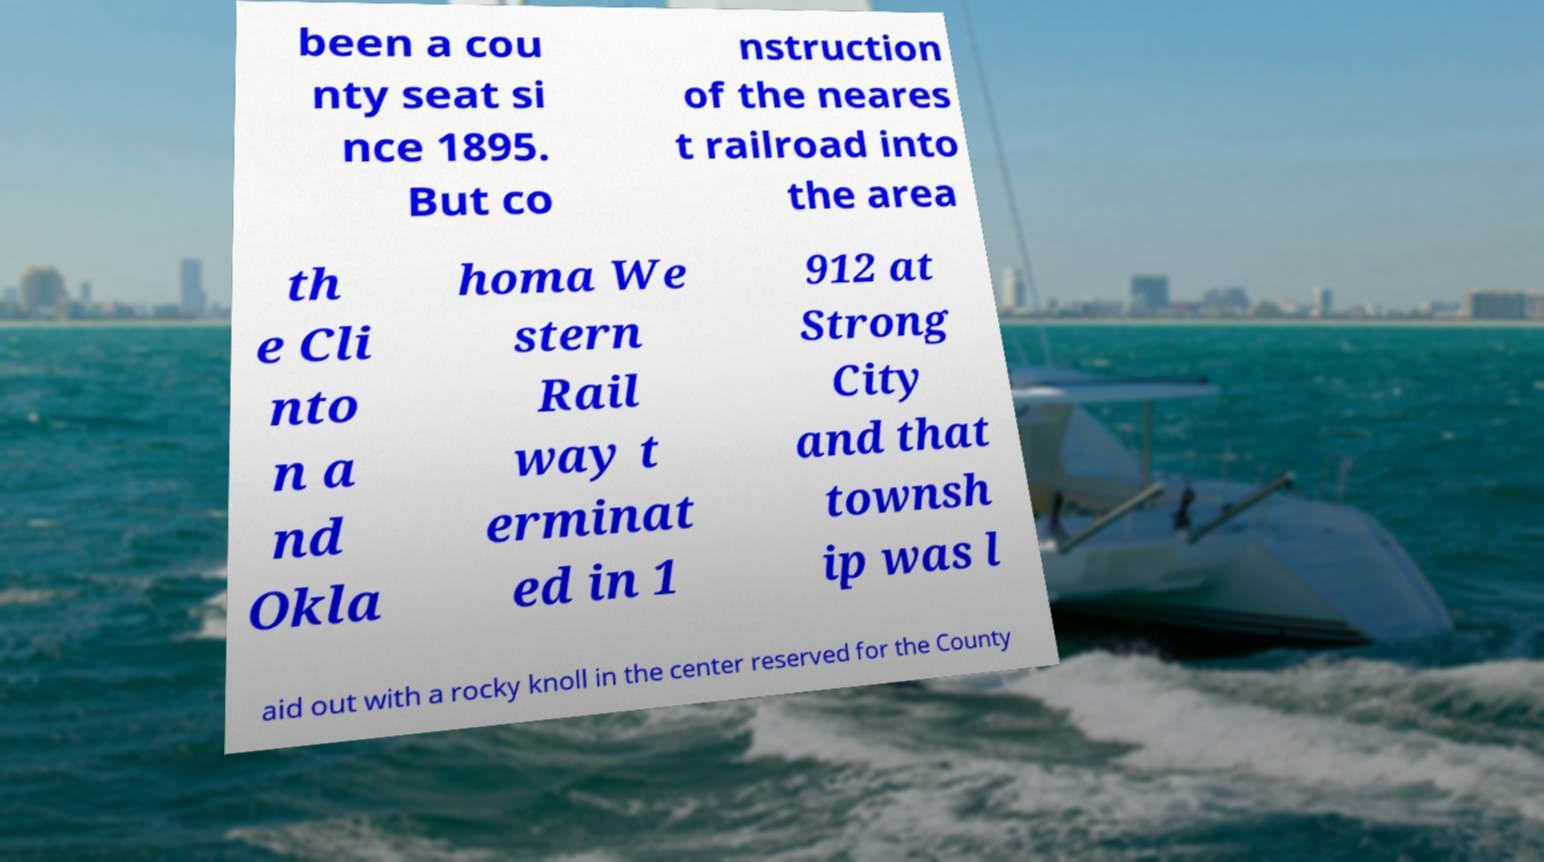Can you accurately transcribe the text from the provided image for me? been a cou nty seat si nce 1895. But co nstruction of the neares t railroad into the area th e Cli nto n a nd Okla homa We stern Rail way t erminat ed in 1 912 at Strong City and that townsh ip was l aid out with a rocky knoll in the center reserved for the County 